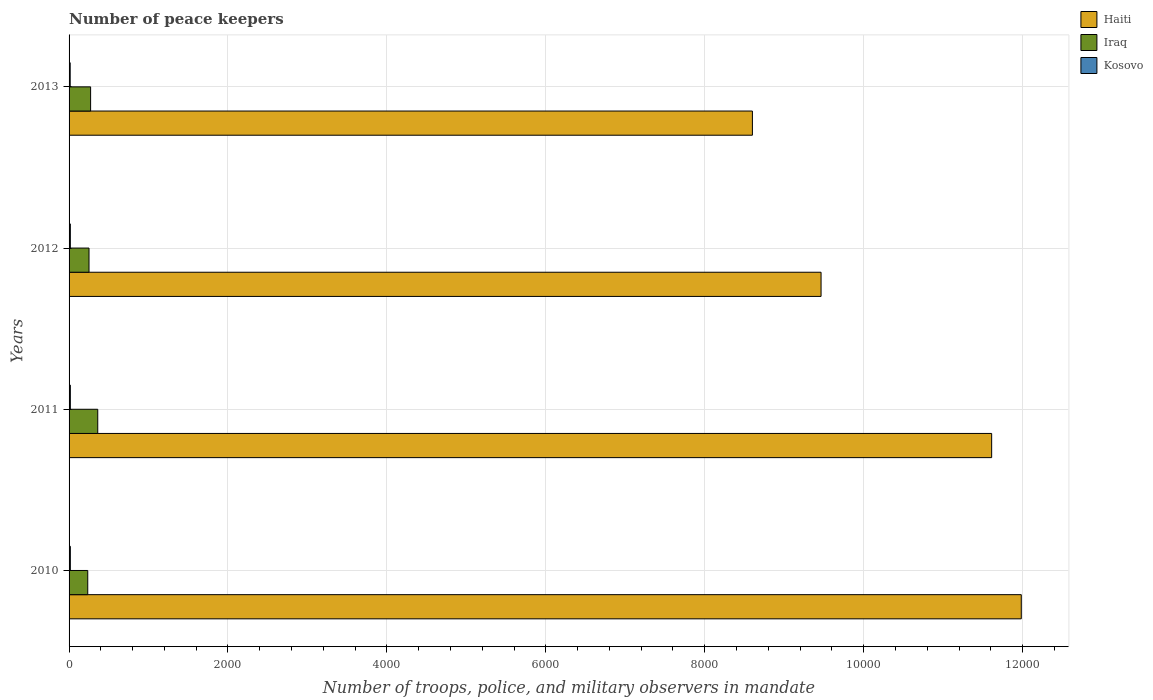What is the label of the 2nd group of bars from the top?
Make the answer very short. 2012. In how many cases, is the number of bars for a given year not equal to the number of legend labels?
Keep it short and to the point. 0. What is the number of peace keepers in in Iraq in 2010?
Offer a terse response. 235. Across all years, what is the maximum number of peace keepers in in Haiti?
Make the answer very short. 1.20e+04. Across all years, what is the minimum number of peace keepers in in Iraq?
Ensure brevity in your answer.  235. In which year was the number of peace keepers in in Iraq maximum?
Ensure brevity in your answer.  2011. In which year was the number of peace keepers in in Haiti minimum?
Provide a succinct answer. 2013. What is the total number of peace keepers in in Haiti in the graph?
Your response must be concise. 4.17e+04. What is the difference between the number of peace keepers in in Haiti in 2010 and that in 2012?
Offer a very short reply. 2520. What is the difference between the number of peace keepers in in Iraq in 2011 and the number of peace keepers in in Haiti in 2012?
Provide a succinct answer. -9103. What is the average number of peace keepers in in Iraq per year?
Provide a short and direct response. 279.5. In the year 2013, what is the difference between the number of peace keepers in in Haiti and number of peace keepers in in Kosovo?
Offer a very short reply. 8586. In how many years, is the number of peace keepers in in Kosovo greater than 9200 ?
Your response must be concise. 0. What is the ratio of the number of peace keepers in in Iraq in 2012 to that in 2013?
Your response must be concise. 0.93. Is the number of peace keepers in in Haiti in 2010 less than that in 2012?
Provide a succinct answer. No. Is the difference between the number of peace keepers in in Haiti in 2010 and 2011 greater than the difference between the number of peace keepers in in Kosovo in 2010 and 2011?
Offer a terse response. Yes. What is the difference between the highest and the second highest number of peace keepers in in Kosovo?
Ensure brevity in your answer.  0. What is the difference between the highest and the lowest number of peace keepers in in Kosovo?
Give a very brief answer. 2. What does the 3rd bar from the top in 2012 represents?
Make the answer very short. Haiti. What does the 2nd bar from the bottom in 2010 represents?
Give a very brief answer. Iraq. How many years are there in the graph?
Keep it short and to the point. 4. What is the difference between two consecutive major ticks on the X-axis?
Give a very brief answer. 2000. How are the legend labels stacked?
Offer a very short reply. Vertical. What is the title of the graph?
Your answer should be compact. Number of peace keepers. What is the label or title of the X-axis?
Offer a terse response. Number of troops, police, and military observers in mandate. What is the Number of troops, police, and military observers in mandate in Haiti in 2010?
Provide a succinct answer. 1.20e+04. What is the Number of troops, police, and military observers in mandate of Iraq in 2010?
Provide a succinct answer. 235. What is the Number of troops, police, and military observers in mandate in Kosovo in 2010?
Provide a short and direct response. 16. What is the Number of troops, police, and military observers in mandate of Haiti in 2011?
Your response must be concise. 1.16e+04. What is the Number of troops, police, and military observers in mandate of Iraq in 2011?
Provide a succinct answer. 361. What is the Number of troops, police, and military observers in mandate of Haiti in 2012?
Provide a succinct answer. 9464. What is the Number of troops, police, and military observers in mandate in Iraq in 2012?
Ensure brevity in your answer.  251. What is the Number of troops, police, and military observers in mandate in Kosovo in 2012?
Your response must be concise. 16. What is the Number of troops, police, and military observers in mandate of Haiti in 2013?
Keep it short and to the point. 8600. What is the Number of troops, police, and military observers in mandate in Iraq in 2013?
Give a very brief answer. 271. What is the Number of troops, police, and military observers in mandate in Kosovo in 2013?
Offer a very short reply. 14. Across all years, what is the maximum Number of troops, police, and military observers in mandate in Haiti?
Offer a very short reply. 1.20e+04. Across all years, what is the maximum Number of troops, police, and military observers in mandate in Iraq?
Your answer should be compact. 361. Across all years, what is the minimum Number of troops, police, and military observers in mandate of Haiti?
Offer a very short reply. 8600. Across all years, what is the minimum Number of troops, police, and military observers in mandate in Iraq?
Ensure brevity in your answer.  235. What is the total Number of troops, police, and military observers in mandate in Haiti in the graph?
Provide a short and direct response. 4.17e+04. What is the total Number of troops, police, and military observers in mandate in Iraq in the graph?
Offer a very short reply. 1118. What is the difference between the Number of troops, police, and military observers in mandate in Haiti in 2010 and that in 2011?
Give a very brief answer. 373. What is the difference between the Number of troops, police, and military observers in mandate of Iraq in 2010 and that in 2011?
Your answer should be compact. -126. What is the difference between the Number of troops, police, and military observers in mandate of Haiti in 2010 and that in 2012?
Your answer should be compact. 2520. What is the difference between the Number of troops, police, and military observers in mandate in Iraq in 2010 and that in 2012?
Your answer should be compact. -16. What is the difference between the Number of troops, police, and military observers in mandate of Haiti in 2010 and that in 2013?
Keep it short and to the point. 3384. What is the difference between the Number of troops, police, and military observers in mandate of Iraq in 2010 and that in 2013?
Make the answer very short. -36. What is the difference between the Number of troops, police, and military observers in mandate of Kosovo in 2010 and that in 2013?
Provide a succinct answer. 2. What is the difference between the Number of troops, police, and military observers in mandate of Haiti in 2011 and that in 2012?
Give a very brief answer. 2147. What is the difference between the Number of troops, police, and military observers in mandate in Iraq in 2011 and that in 2012?
Offer a terse response. 110. What is the difference between the Number of troops, police, and military observers in mandate of Haiti in 2011 and that in 2013?
Offer a terse response. 3011. What is the difference between the Number of troops, police, and military observers in mandate in Kosovo in 2011 and that in 2013?
Offer a terse response. 2. What is the difference between the Number of troops, police, and military observers in mandate of Haiti in 2012 and that in 2013?
Your response must be concise. 864. What is the difference between the Number of troops, police, and military observers in mandate of Kosovo in 2012 and that in 2013?
Give a very brief answer. 2. What is the difference between the Number of troops, police, and military observers in mandate in Haiti in 2010 and the Number of troops, police, and military observers in mandate in Iraq in 2011?
Your answer should be compact. 1.16e+04. What is the difference between the Number of troops, police, and military observers in mandate of Haiti in 2010 and the Number of troops, police, and military observers in mandate of Kosovo in 2011?
Give a very brief answer. 1.20e+04. What is the difference between the Number of troops, police, and military observers in mandate of Iraq in 2010 and the Number of troops, police, and military observers in mandate of Kosovo in 2011?
Make the answer very short. 219. What is the difference between the Number of troops, police, and military observers in mandate in Haiti in 2010 and the Number of troops, police, and military observers in mandate in Iraq in 2012?
Ensure brevity in your answer.  1.17e+04. What is the difference between the Number of troops, police, and military observers in mandate in Haiti in 2010 and the Number of troops, police, and military observers in mandate in Kosovo in 2012?
Offer a terse response. 1.20e+04. What is the difference between the Number of troops, police, and military observers in mandate of Iraq in 2010 and the Number of troops, police, and military observers in mandate of Kosovo in 2012?
Provide a succinct answer. 219. What is the difference between the Number of troops, police, and military observers in mandate in Haiti in 2010 and the Number of troops, police, and military observers in mandate in Iraq in 2013?
Provide a short and direct response. 1.17e+04. What is the difference between the Number of troops, police, and military observers in mandate of Haiti in 2010 and the Number of troops, police, and military observers in mandate of Kosovo in 2013?
Provide a succinct answer. 1.20e+04. What is the difference between the Number of troops, police, and military observers in mandate in Iraq in 2010 and the Number of troops, police, and military observers in mandate in Kosovo in 2013?
Provide a short and direct response. 221. What is the difference between the Number of troops, police, and military observers in mandate in Haiti in 2011 and the Number of troops, police, and military observers in mandate in Iraq in 2012?
Keep it short and to the point. 1.14e+04. What is the difference between the Number of troops, police, and military observers in mandate of Haiti in 2011 and the Number of troops, police, and military observers in mandate of Kosovo in 2012?
Provide a short and direct response. 1.16e+04. What is the difference between the Number of troops, police, and military observers in mandate of Iraq in 2011 and the Number of troops, police, and military observers in mandate of Kosovo in 2012?
Make the answer very short. 345. What is the difference between the Number of troops, police, and military observers in mandate in Haiti in 2011 and the Number of troops, police, and military observers in mandate in Iraq in 2013?
Provide a short and direct response. 1.13e+04. What is the difference between the Number of troops, police, and military observers in mandate in Haiti in 2011 and the Number of troops, police, and military observers in mandate in Kosovo in 2013?
Provide a short and direct response. 1.16e+04. What is the difference between the Number of troops, police, and military observers in mandate in Iraq in 2011 and the Number of troops, police, and military observers in mandate in Kosovo in 2013?
Keep it short and to the point. 347. What is the difference between the Number of troops, police, and military observers in mandate of Haiti in 2012 and the Number of troops, police, and military observers in mandate of Iraq in 2013?
Your answer should be very brief. 9193. What is the difference between the Number of troops, police, and military observers in mandate of Haiti in 2012 and the Number of troops, police, and military observers in mandate of Kosovo in 2013?
Your response must be concise. 9450. What is the difference between the Number of troops, police, and military observers in mandate in Iraq in 2012 and the Number of troops, police, and military observers in mandate in Kosovo in 2013?
Your response must be concise. 237. What is the average Number of troops, police, and military observers in mandate in Haiti per year?
Give a very brief answer. 1.04e+04. What is the average Number of troops, police, and military observers in mandate of Iraq per year?
Your answer should be compact. 279.5. In the year 2010, what is the difference between the Number of troops, police, and military observers in mandate in Haiti and Number of troops, police, and military observers in mandate in Iraq?
Provide a short and direct response. 1.17e+04. In the year 2010, what is the difference between the Number of troops, police, and military observers in mandate of Haiti and Number of troops, police, and military observers in mandate of Kosovo?
Offer a very short reply. 1.20e+04. In the year 2010, what is the difference between the Number of troops, police, and military observers in mandate of Iraq and Number of troops, police, and military observers in mandate of Kosovo?
Ensure brevity in your answer.  219. In the year 2011, what is the difference between the Number of troops, police, and military observers in mandate in Haiti and Number of troops, police, and military observers in mandate in Iraq?
Give a very brief answer. 1.12e+04. In the year 2011, what is the difference between the Number of troops, police, and military observers in mandate in Haiti and Number of troops, police, and military observers in mandate in Kosovo?
Make the answer very short. 1.16e+04. In the year 2011, what is the difference between the Number of troops, police, and military observers in mandate of Iraq and Number of troops, police, and military observers in mandate of Kosovo?
Keep it short and to the point. 345. In the year 2012, what is the difference between the Number of troops, police, and military observers in mandate in Haiti and Number of troops, police, and military observers in mandate in Iraq?
Ensure brevity in your answer.  9213. In the year 2012, what is the difference between the Number of troops, police, and military observers in mandate of Haiti and Number of troops, police, and military observers in mandate of Kosovo?
Offer a terse response. 9448. In the year 2012, what is the difference between the Number of troops, police, and military observers in mandate of Iraq and Number of troops, police, and military observers in mandate of Kosovo?
Make the answer very short. 235. In the year 2013, what is the difference between the Number of troops, police, and military observers in mandate of Haiti and Number of troops, police, and military observers in mandate of Iraq?
Offer a terse response. 8329. In the year 2013, what is the difference between the Number of troops, police, and military observers in mandate in Haiti and Number of troops, police, and military observers in mandate in Kosovo?
Provide a short and direct response. 8586. In the year 2013, what is the difference between the Number of troops, police, and military observers in mandate in Iraq and Number of troops, police, and military observers in mandate in Kosovo?
Offer a very short reply. 257. What is the ratio of the Number of troops, police, and military observers in mandate in Haiti in 2010 to that in 2011?
Offer a terse response. 1.03. What is the ratio of the Number of troops, police, and military observers in mandate in Iraq in 2010 to that in 2011?
Offer a terse response. 0.65. What is the ratio of the Number of troops, police, and military observers in mandate of Haiti in 2010 to that in 2012?
Your response must be concise. 1.27. What is the ratio of the Number of troops, police, and military observers in mandate in Iraq in 2010 to that in 2012?
Keep it short and to the point. 0.94. What is the ratio of the Number of troops, police, and military observers in mandate in Haiti in 2010 to that in 2013?
Provide a succinct answer. 1.39. What is the ratio of the Number of troops, police, and military observers in mandate of Iraq in 2010 to that in 2013?
Give a very brief answer. 0.87. What is the ratio of the Number of troops, police, and military observers in mandate in Haiti in 2011 to that in 2012?
Your response must be concise. 1.23. What is the ratio of the Number of troops, police, and military observers in mandate in Iraq in 2011 to that in 2012?
Provide a succinct answer. 1.44. What is the ratio of the Number of troops, police, and military observers in mandate of Kosovo in 2011 to that in 2012?
Keep it short and to the point. 1. What is the ratio of the Number of troops, police, and military observers in mandate in Haiti in 2011 to that in 2013?
Offer a very short reply. 1.35. What is the ratio of the Number of troops, police, and military observers in mandate of Iraq in 2011 to that in 2013?
Offer a terse response. 1.33. What is the ratio of the Number of troops, police, and military observers in mandate of Haiti in 2012 to that in 2013?
Ensure brevity in your answer.  1.1. What is the ratio of the Number of troops, police, and military observers in mandate in Iraq in 2012 to that in 2013?
Make the answer very short. 0.93. What is the difference between the highest and the second highest Number of troops, police, and military observers in mandate of Haiti?
Keep it short and to the point. 373. What is the difference between the highest and the second highest Number of troops, police, and military observers in mandate in Iraq?
Ensure brevity in your answer.  90. What is the difference between the highest and the lowest Number of troops, police, and military observers in mandate of Haiti?
Offer a terse response. 3384. What is the difference between the highest and the lowest Number of troops, police, and military observers in mandate in Iraq?
Give a very brief answer. 126. 